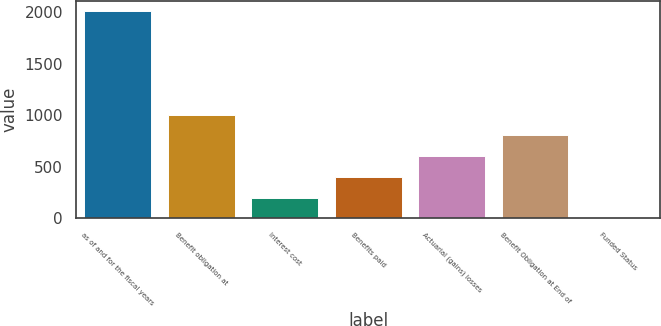<chart> <loc_0><loc_0><loc_500><loc_500><bar_chart><fcel>as of and for the fiscal years<fcel>Benefit obligation at<fcel>Interest cost<fcel>Benefits paid<fcel>Actuarial (gains) losses<fcel>Benefit Obligation at End of<fcel>Funded Status<nl><fcel>2013<fcel>1006.65<fcel>201.57<fcel>402.84<fcel>604.11<fcel>805.38<fcel>0.3<nl></chart> 